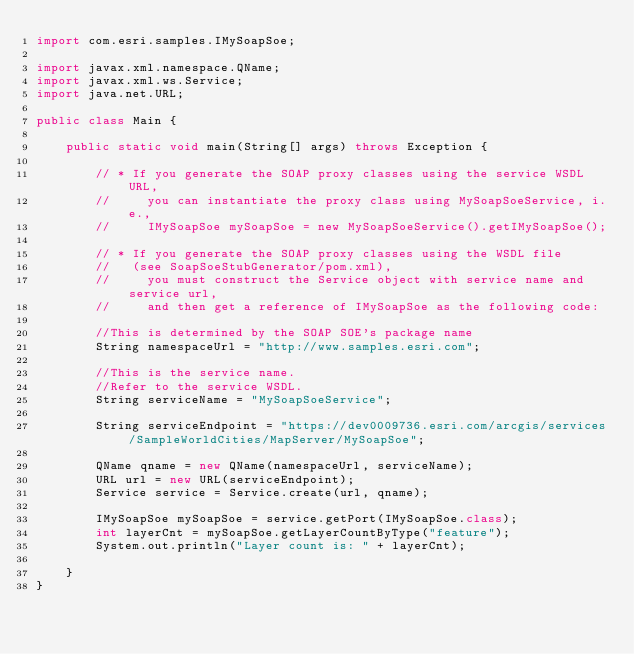Convert code to text. <code><loc_0><loc_0><loc_500><loc_500><_Java_>import com.esri.samples.IMySoapSoe;

import javax.xml.namespace.QName;
import javax.xml.ws.Service;
import java.net.URL;

public class Main {

    public static void main(String[] args) throws Exception {

        // * If you generate the SOAP proxy classes using the service WSDL URL,
        //     you can instantiate the proxy class using MySoapSoeService, i.e.,
        //     IMySoapSoe mySoapSoe = new MySoapSoeService().getIMySoapSoe();

        // * If you generate the SOAP proxy classes using the WSDL file
        //   (see SoapSoeStubGenerator/pom.xml),
        //     you must construct the Service object with service name and service url,
        //     and then get a reference of IMySoapSoe as the following code:

        //This is determined by the SOAP SOE's package name
        String namespaceUrl = "http://www.samples.esri.com";

        //This is the service name.
        //Refer to the service WSDL.
        String serviceName = "MySoapSoeService";

        String serviceEndpoint = "https://dev0009736.esri.com/arcgis/services/SampleWorldCities/MapServer/MySoapSoe";

        QName qname = new QName(namespaceUrl, serviceName);
        URL url = new URL(serviceEndpoint);
        Service service = Service.create(url, qname);

        IMySoapSoe mySoapSoe = service.getPort(IMySoapSoe.class);
        int layerCnt = mySoapSoe.getLayerCountByType("feature");
        System.out.println("Layer count is: " + layerCnt);

    }
}
</code> 